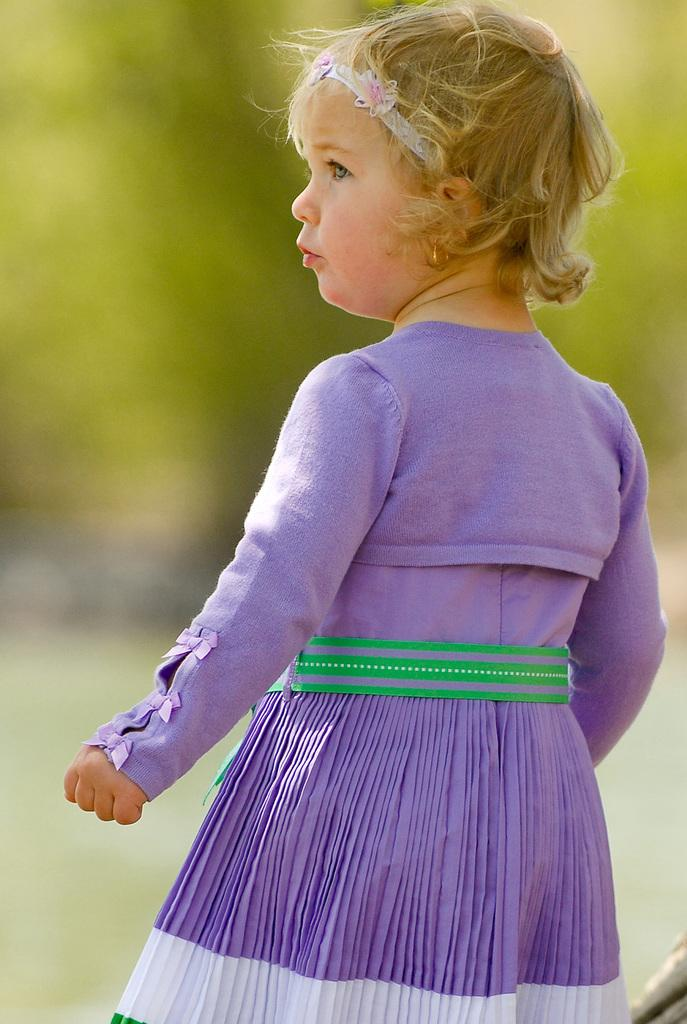Who is the main subject in the image? There is a girl in the image. What is the girl doing in the image? The girl is standing. What color are the clothes the girl is wearing? The girl is wearing purple color clothes. Is there a water-filled sink visible in the image? No, there is no sink or water visible in the image. 